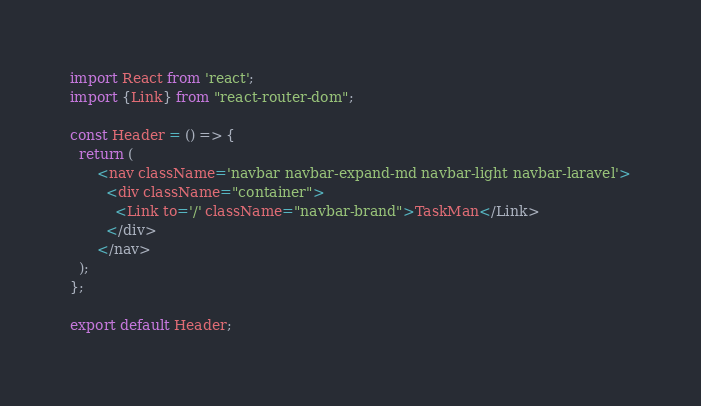<code> <loc_0><loc_0><loc_500><loc_500><_JavaScript_>import React from 'react';
import {Link} from "react-router-dom";

const Header = () => {
  return (
      <nav className='navbar navbar-expand-md navbar-light navbar-laravel'>
        <div className="container">
          <Link to='/' className="navbar-brand">TaskMan</Link>
        </div>
      </nav>
  );
};

export default Header;</code> 